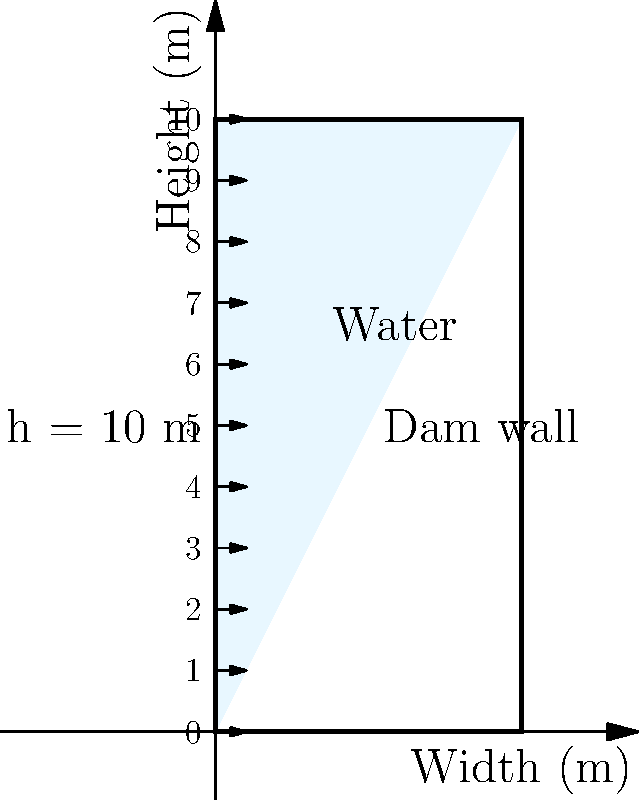In the diagram, a dam wall is shown with a height of 10 meters. The water pressure at the base of the dam is 98.1 kPa. If you were to select a book from your rare Alexander Pope collection that weighs approximately the same as the force exerted by water on 1 square meter at the base of the dam, how heavy would that book be in kilograms? Let's approach this step-by-step:

1) The water pressure at the base of the dam is given as 98.1 kPa.

2) Pressure is force per unit area. So, for 1 square meter:
   
   Force = Pressure × Area
   $F = 98.1 \text{ kPa} \times 1 \text{ m}^2 = 98,100 \text{ N}$

3) To convert this force to mass, we use the relation:
   
   $F = mg$, where $g$ is the acceleration due to gravity (9.81 m/s²)

4) Rearranging the equation:
   
   $m = \frac{F}{g} = \frac{98,100 \text{ N}}{9.81 \text{ m/s}^2} = 10,000 \text{ kg}$

5) Therefore, the force exerted by water on 1 square meter at the base of the dam is equivalent to the weight of a 10,000 kg object.

This is a very heavy "book"! In reality, no single book would weigh this much. This exercise is meant to illustrate the immense pressure water can exert on dam walls.
Answer: 10,000 kg 